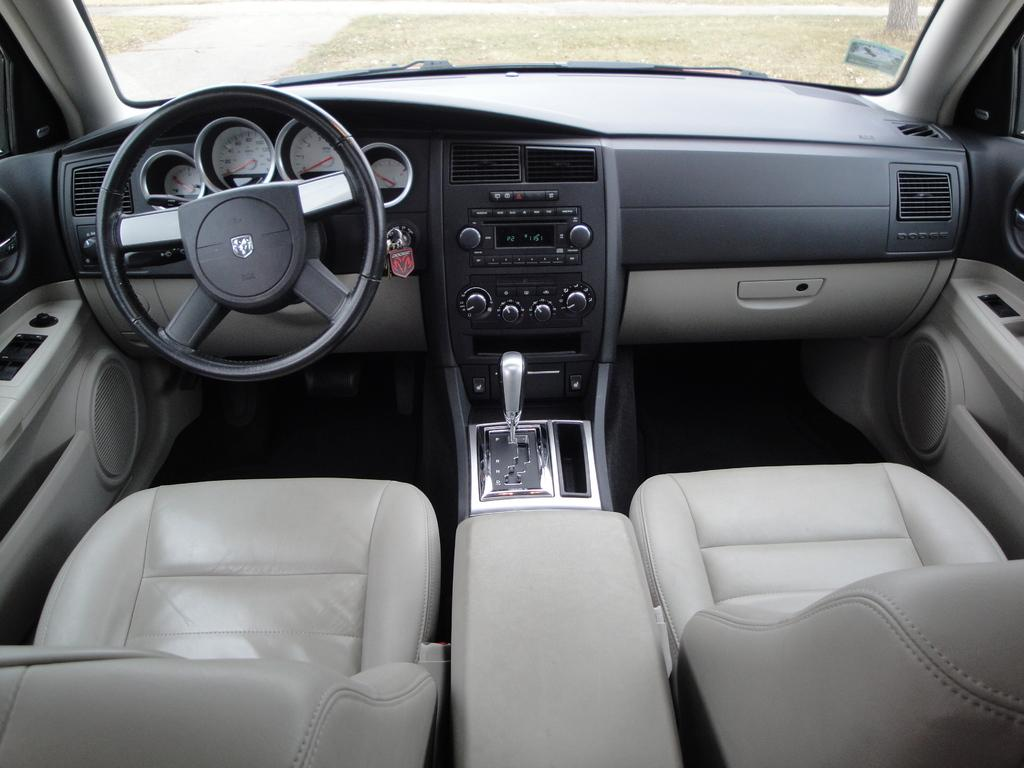What type of object is the main subject in the image? The image contains a vehicle. What feature is present in the vehicle for controlling its direction? The vehicle has a steering wheel. How can the driver change the speed or gear of the vehicle? The vehicle has a gear system. What can be used to monitor the vehicle's performance or status? The vehicle has readings or gauges. What can be pressed or activated to perform specific functions in the vehicle? The vehicle has buttons. What can be used for passengers to sit in the vehicle? The vehicle has seats. Are there any other elements in the vehicle that are not specified? Yes, the vehicle has other unspecified elements. How many fingers can be seen on the bear in the image? There is no bear present in the image, and therefore no fingers can be observed. What command can be given to the vehicle to stop in the image? The image does not show the vehicle in motion, and there is no indication of a command to stop. 